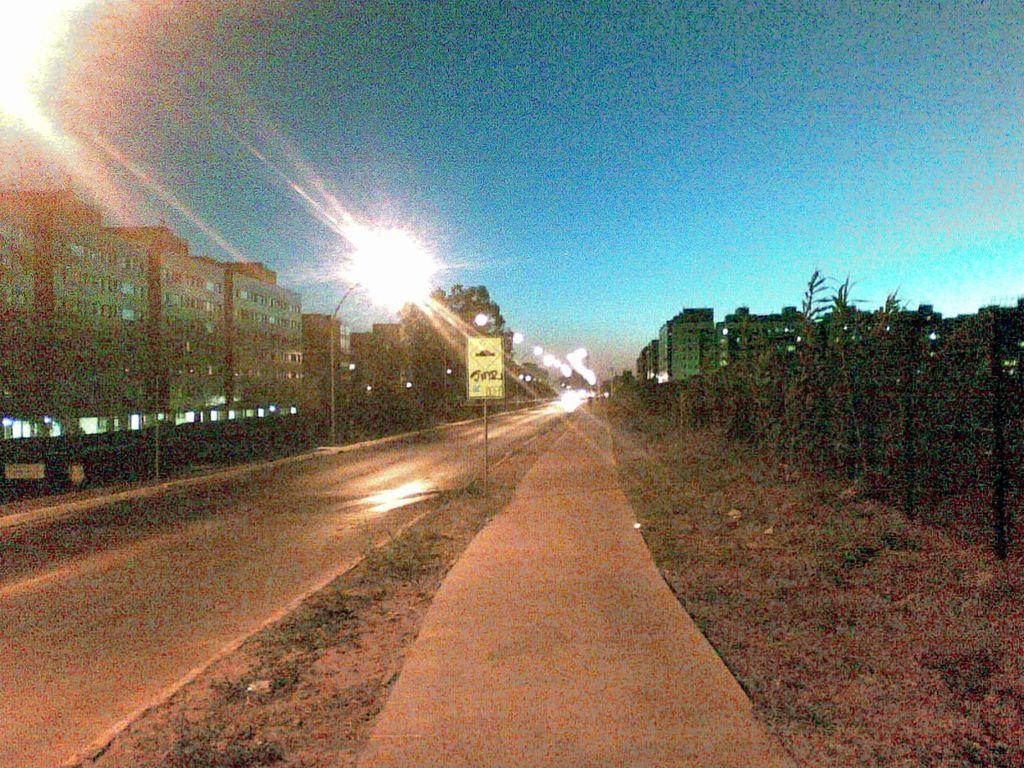Can you describe this image briefly? In this picture I can see the road in front and I see a pole on which there is a board. In the background I see number of buildings and I see the lights and I can also see the sky. 